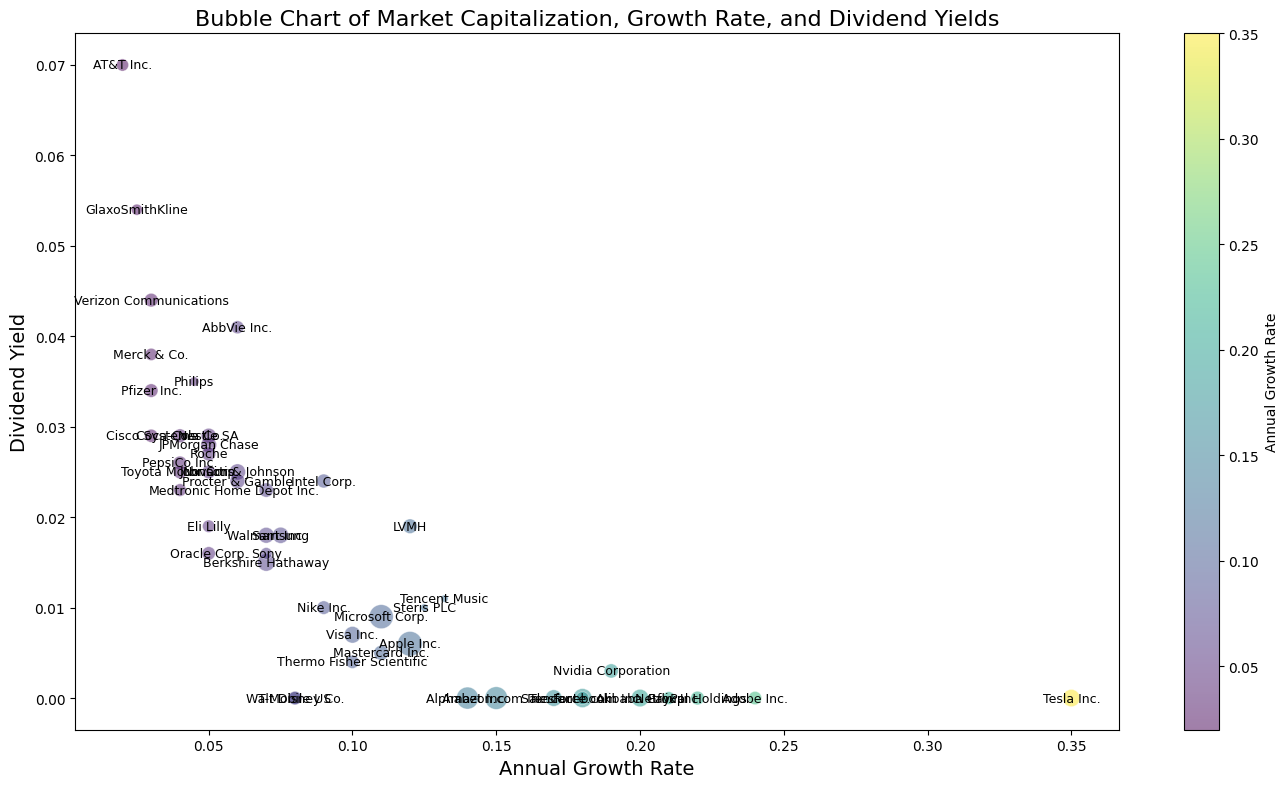What is the average market capitalization of companies with an annual growth rate greater than 0.10? To calculate the average, identify the companies with an annual growth rate greater than 0.10, sum their market capitalizations, and then divide by the number of such companies. The companies are Apple, Microsoft, Amazon, Alphabet, Facebook, Nvidia, PayPal, Netflix, Salesforce, and Adobe. The sum of their market capitalizations is 2450000000000 + 2230000000000 + 1750000000000 + 1560000000000 + 870000000000 + 270000000000 + 235000000000 + 180000000000 + 180000000000 + 210000000000 = 8420000000000. There are 10 companies, so the average is 8420000000000 / 10 = 842000000000.
Answer: 842 billion Which company has the highest dividend yield on the chart? Identify the company with the largest bubble along the dividend yield axis. The highest dividend yield is 0.07 for AT&T Inc.
Answer: AT&T Inc Do most companies with a high growth rate also have a high market capitalization? Observe the distribution of bubbles with high annual growth rates and check their sizes. Most large bubbles towards the right (high growth rates) indicate the same. There are several large bubbles (representing high market capitalization) with high growth rates. For instance, Apple, Amazon, Nvidia, and PayPal.
Answer: Yes Which company offers both substantial market capitalization and high dividend yield? Look for large bubbles positioned high on the dividend yield axis. Berkshire Hathaway, with significant market capitalization and a dividend yield of 0.015 followed by companies such as Pfizer, AbbVie, and Merck.
Answer: Berkshire Hathaway Among companies with no dividend yield, which one has the highest market capitalization? Focus on the bubbles positioned at a dividend yield of 0 and compare their sizes. The largest bubble is Amazon.
Answer: Amazon.com Inc What is the total market capitalization of companies with a dividend yield above 0.03? Identify the companies with a dividend yield above 0.03, sum their market capitalizations. The companies are Verizon, Pfizer, AbbVie, Merck, GlaxoSmithKline, Philips. Summing their market caps: 230000000000 + 220000000000 + 190000000000 + 150000000000 + 100000000000 + 50000000000 = 940000000000.
Answer: 940 billion Do companies with higher dividend yields generally have lower growth rates? Compare the positions of bubbles along the vertical (dividend yield) and horizontal (growth rate) axes. Generally, higher bubbles (higher yields) are to the left (lower growth rates), indicating an inverse relationship.
Answer: Yes Which company has a moderate growth rate and stands out for its size? Find a moderately positioned bubble on the annual growth rate axis with a notable size. Microsoft Corp., with a growth rate of 0.11 and significant size (market capitalization).
Answer: Microsoft Corp What is the average dividend yield of companies in the healthcare sector listed in the figure? (Consider Johnson & Johnson, Pfizer, AbbVie, Merck) Calculate the average by summing the dividend yields of the listed companies and dividing by the number of companies. (0.025 + 0.034 + 0.041 + 0.038) / 4 = 0.0345.
Answer: 0.0345 